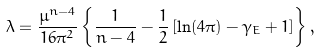Convert formula to latex. <formula><loc_0><loc_0><loc_500><loc_500>\lambda = \frac { \mu ^ { n - 4 } } { 1 6 \pi ^ { 2 } } \left \{ \frac { 1 } { n - 4 } - \frac { 1 } { 2 } \left [ \ln ( 4 \pi ) - \gamma _ { E } + 1 \right ] \right \} ,</formula> 